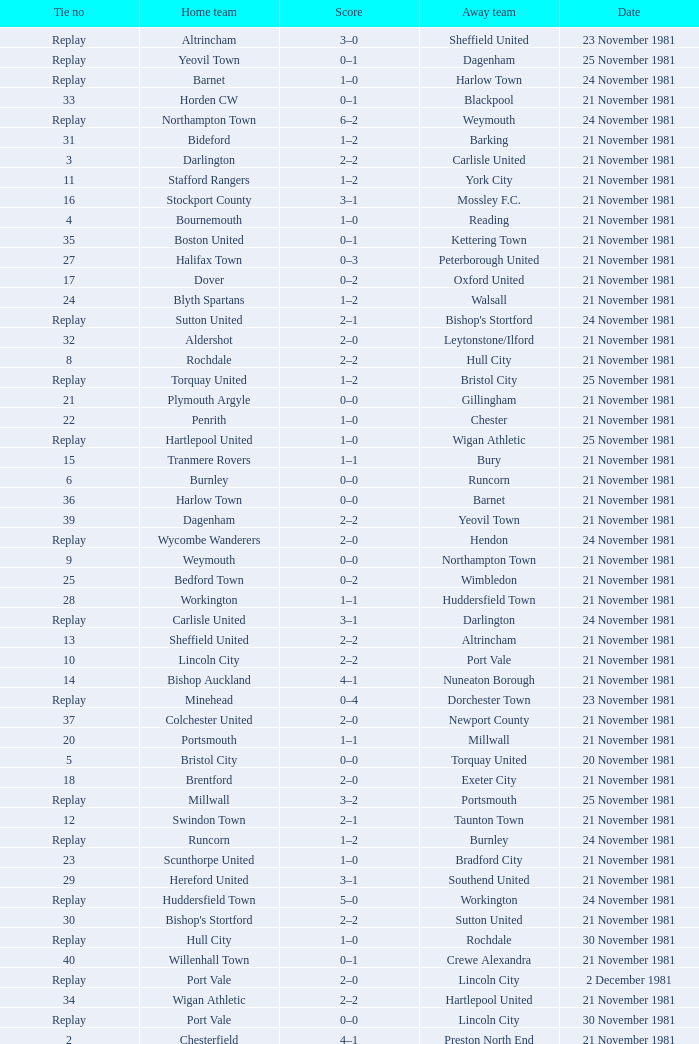What is enfield's tie number? 1.0. 